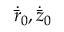<formula> <loc_0><loc_0><loc_500><loc_500>\dot { \bar { r } } _ { 0 } , \dot { \bar { z } } _ { 0 }</formula> 